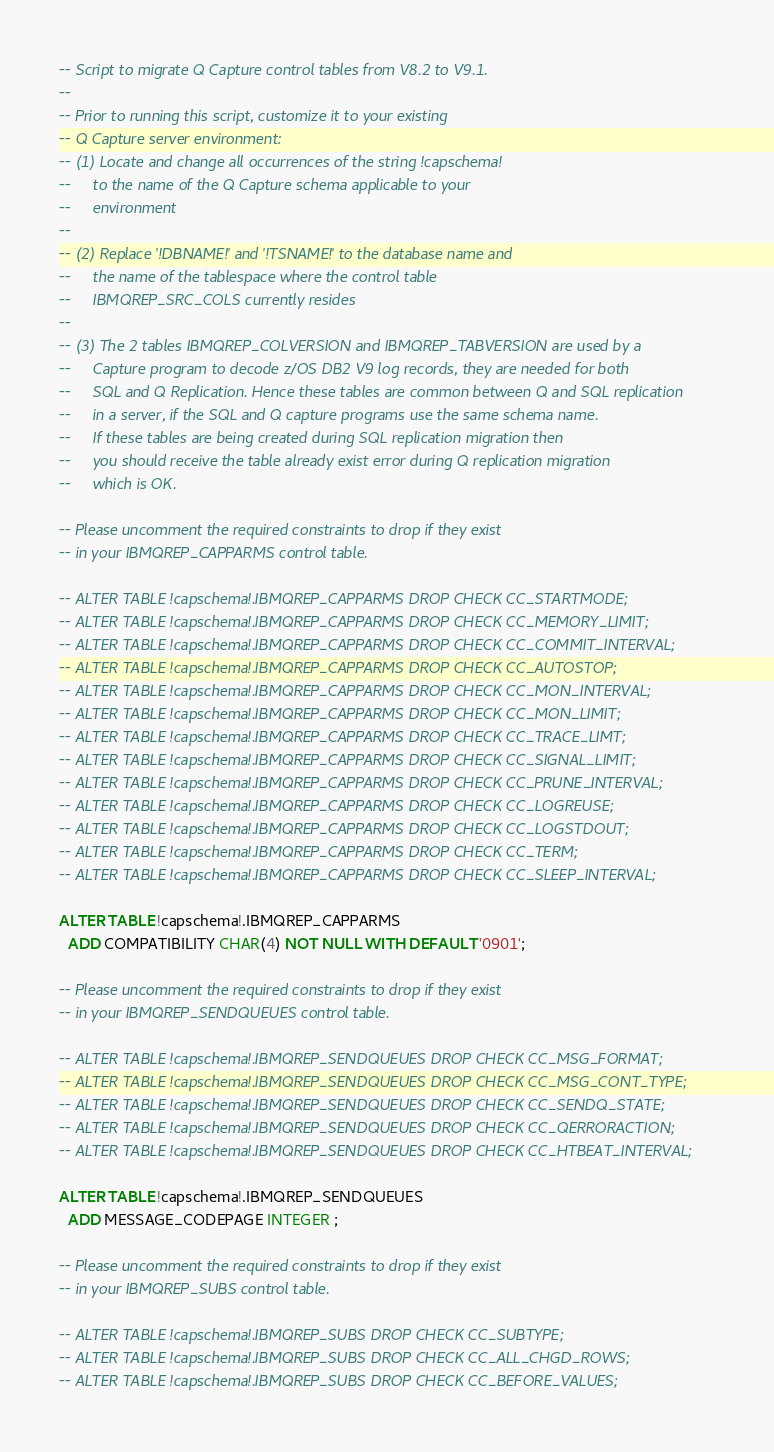<code> <loc_0><loc_0><loc_500><loc_500><_SQL_>-- Script to migrate Q Capture control tables from V8.2 to V9.1.
--
-- Prior to running this script, customize it to your existing 
-- Q Capture server environment:
-- (1) Locate and change all occurrences of the string !capschema! 
--     to the name of the Q Capture schema applicable to your
--     environment
--
-- (2) Replace '!DBNAME!' and '!TSNAME!' to the database name and 
--     the name of the tablespace where the control table 
--     IBMQREP_SRC_COLS currently resides
--
-- (3) The 2 tables IBMQREP_COLVERSION and IBMQREP_TABVERSION are used by a 
--     Capture program to decode z/OS DB2 V9 log records, they are needed for both 
--     SQL and Q Replication. Hence these tables are common between Q and SQL replication 
--     in a server, if the SQL and Q capture programs use the same schema name. 
--     If these tables are being created during SQL replication migration then 
--     you should receive the table already exist error during Q replication migration  
--     which is OK.

-- Please uncomment the required constraints to drop if they exist
-- in your IBMQREP_CAPPARMS control table.

-- ALTER TABLE !capschema!.IBMQREP_CAPPARMS DROP CHECK CC_STARTMODE;
-- ALTER TABLE !capschema!.IBMQREP_CAPPARMS DROP CHECK CC_MEMORY_LIMIT;
-- ALTER TABLE !capschema!.IBMQREP_CAPPARMS DROP CHECK CC_COMMIT_INTERVAL;
-- ALTER TABLE !capschema!.IBMQREP_CAPPARMS DROP CHECK CC_AUTOSTOP;
-- ALTER TABLE !capschema!.IBMQREP_CAPPARMS DROP CHECK CC_MON_INTERVAL;
-- ALTER TABLE !capschema!.IBMQREP_CAPPARMS DROP CHECK CC_MON_LIMIT;
-- ALTER TABLE !capschema!.IBMQREP_CAPPARMS DROP CHECK CC_TRACE_LIMT;
-- ALTER TABLE !capschema!.IBMQREP_CAPPARMS DROP CHECK CC_SIGNAL_LIMIT;
-- ALTER TABLE !capschema!.IBMQREP_CAPPARMS DROP CHECK CC_PRUNE_INTERVAL;
-- ALTER TABLE !capschema!.IBMQREP_CAPPARMS DROP CHECK CC_LOGREUSE;
-- ALTER TABLE !capschema!.IBMQREP_CAPPARMS DROP CHECK CC_LOGSTDOUT;
-- ALTER TABLE !capschema!.IBMQREP_CAPPARMS DROP CHECK CC_TERM;
-- ALTER TABLE !capschema!.IBMQREP_CAPPARMS DROP CHECK CC_SLEEP_INTERVAL;

ALTER TABLE !capschema!.IBMQREP_CAPPARMS
  ADD COMPATIBILITY CHAR(4) NOT NULL WITH DEFAULT '0901';
  
-- Please uncomment the required constraints to drop if they exist
-- in your IBMQREP_SENDQUEUES control table.

-- ALTER TABLE !capschema!.IBMQREP_SENDQUEUES DROP CHECK CC_MSG_FORMAT;
-- ALTER TABLE !capschema!.IBMQREP_SENDQUEUES DROP CHECK CC_MSG_CONT_TYPE;
-- ALTER TABLE !capschema!.IBMQREP_SENDQUEUES DROP CHECK CC_SENDQ_STATE;
-- ALTER TABLE !capschema!.IBMQREP_SENDQUEUES DROP CHECK CC_QERRORACTION;
-- ALTER TABLE !capschema!.IBMQREP_SENDQUEUES DROP CHECK CC_HTBEAT_INTERVAL;

ALTER TABLE !capschema!.IBMQREP_SENDQUEUES
  ADD MESSAGE_CODEPAGE INTEGER ; 

-- Please uncomment the required constraints to drop if they exist
-- in your IBMQREP_SUBS control table.
  
-- ALTER TABLE !capschema!.IBMQREP_SUBS DROP CHECK CC_SUBTYPE;
-- ALTER TABLE !capschema!.IBMQREP_SUBS DROP CHECK CC_ALL_CHGD_ROWS;
-- ALTER TABLE !capschema!.IBMQREP_SUBS DROP CHECK CC_BEFORE_VALUES;</code> 